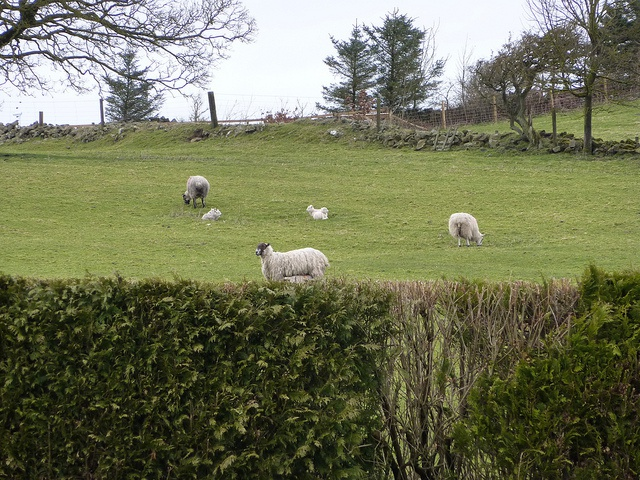Describe the objects in this image and their specific colors. I can see sheep in gray, darkgray, and lightgray tones, sheep in gray, olive, darkgray, and lightgray tones, sheep in gray, darkgray, black, and lightgray tones, sheep in gray, lightgray, darkgray, and olive tones, and sheep in gray, darkgray, and lightgray tones in this image. 